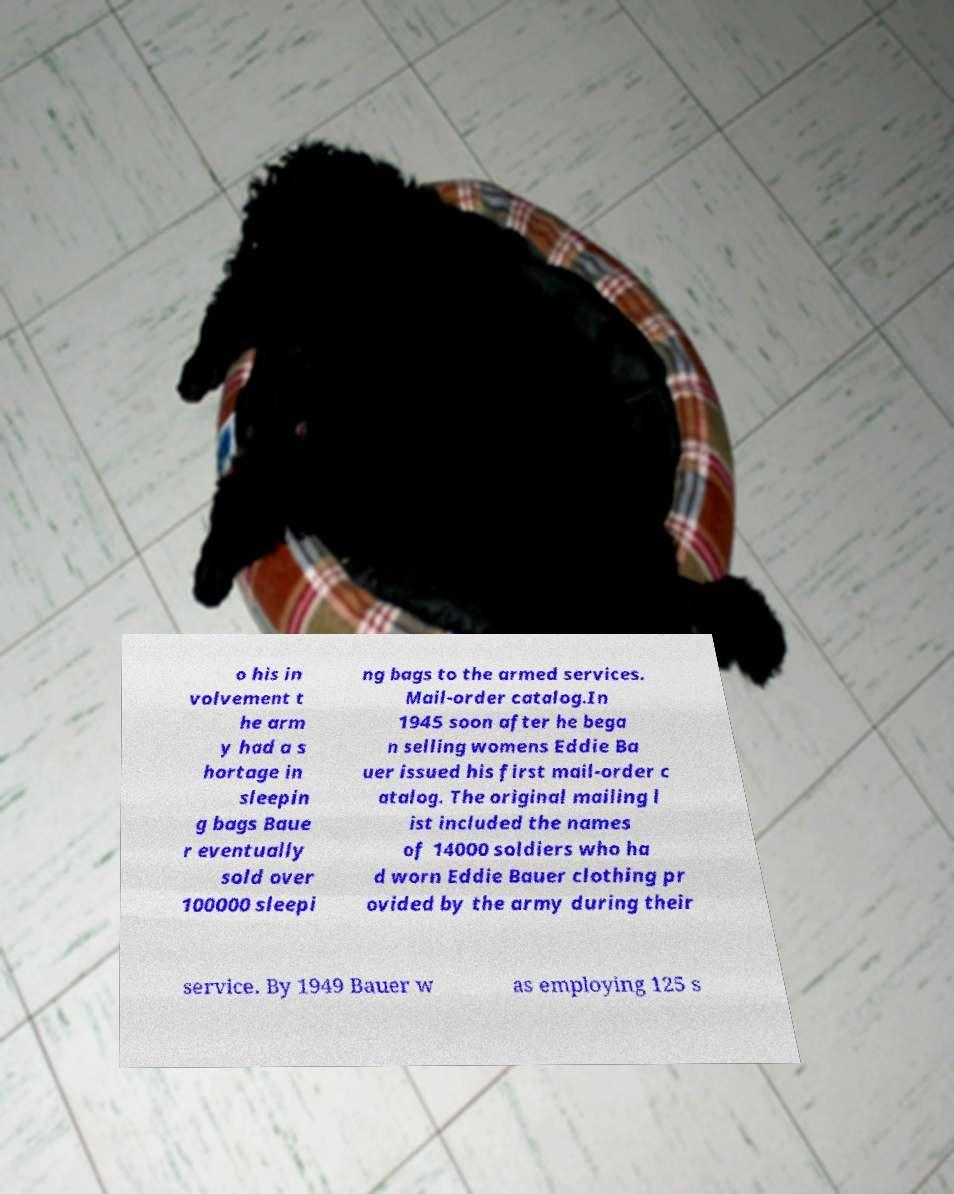Could you assist in decoding the text presented in this image and type it out clearly? o his in volvement t he arm y had a s hortage in sleepin g bags Baue r eventually sold over 100000 sleepi ng bags to the armed services. Mail-order catalog.In 1945 soon after he bega n selling womens Eddie Ba uer issued his first mail-order c atalog. The original mailing l ist included the names of 14000 soldiers who ha d worn Eddie Bauer clothing pr ovided by the army during their service. By 1949 Bauer w as employing 125 s 